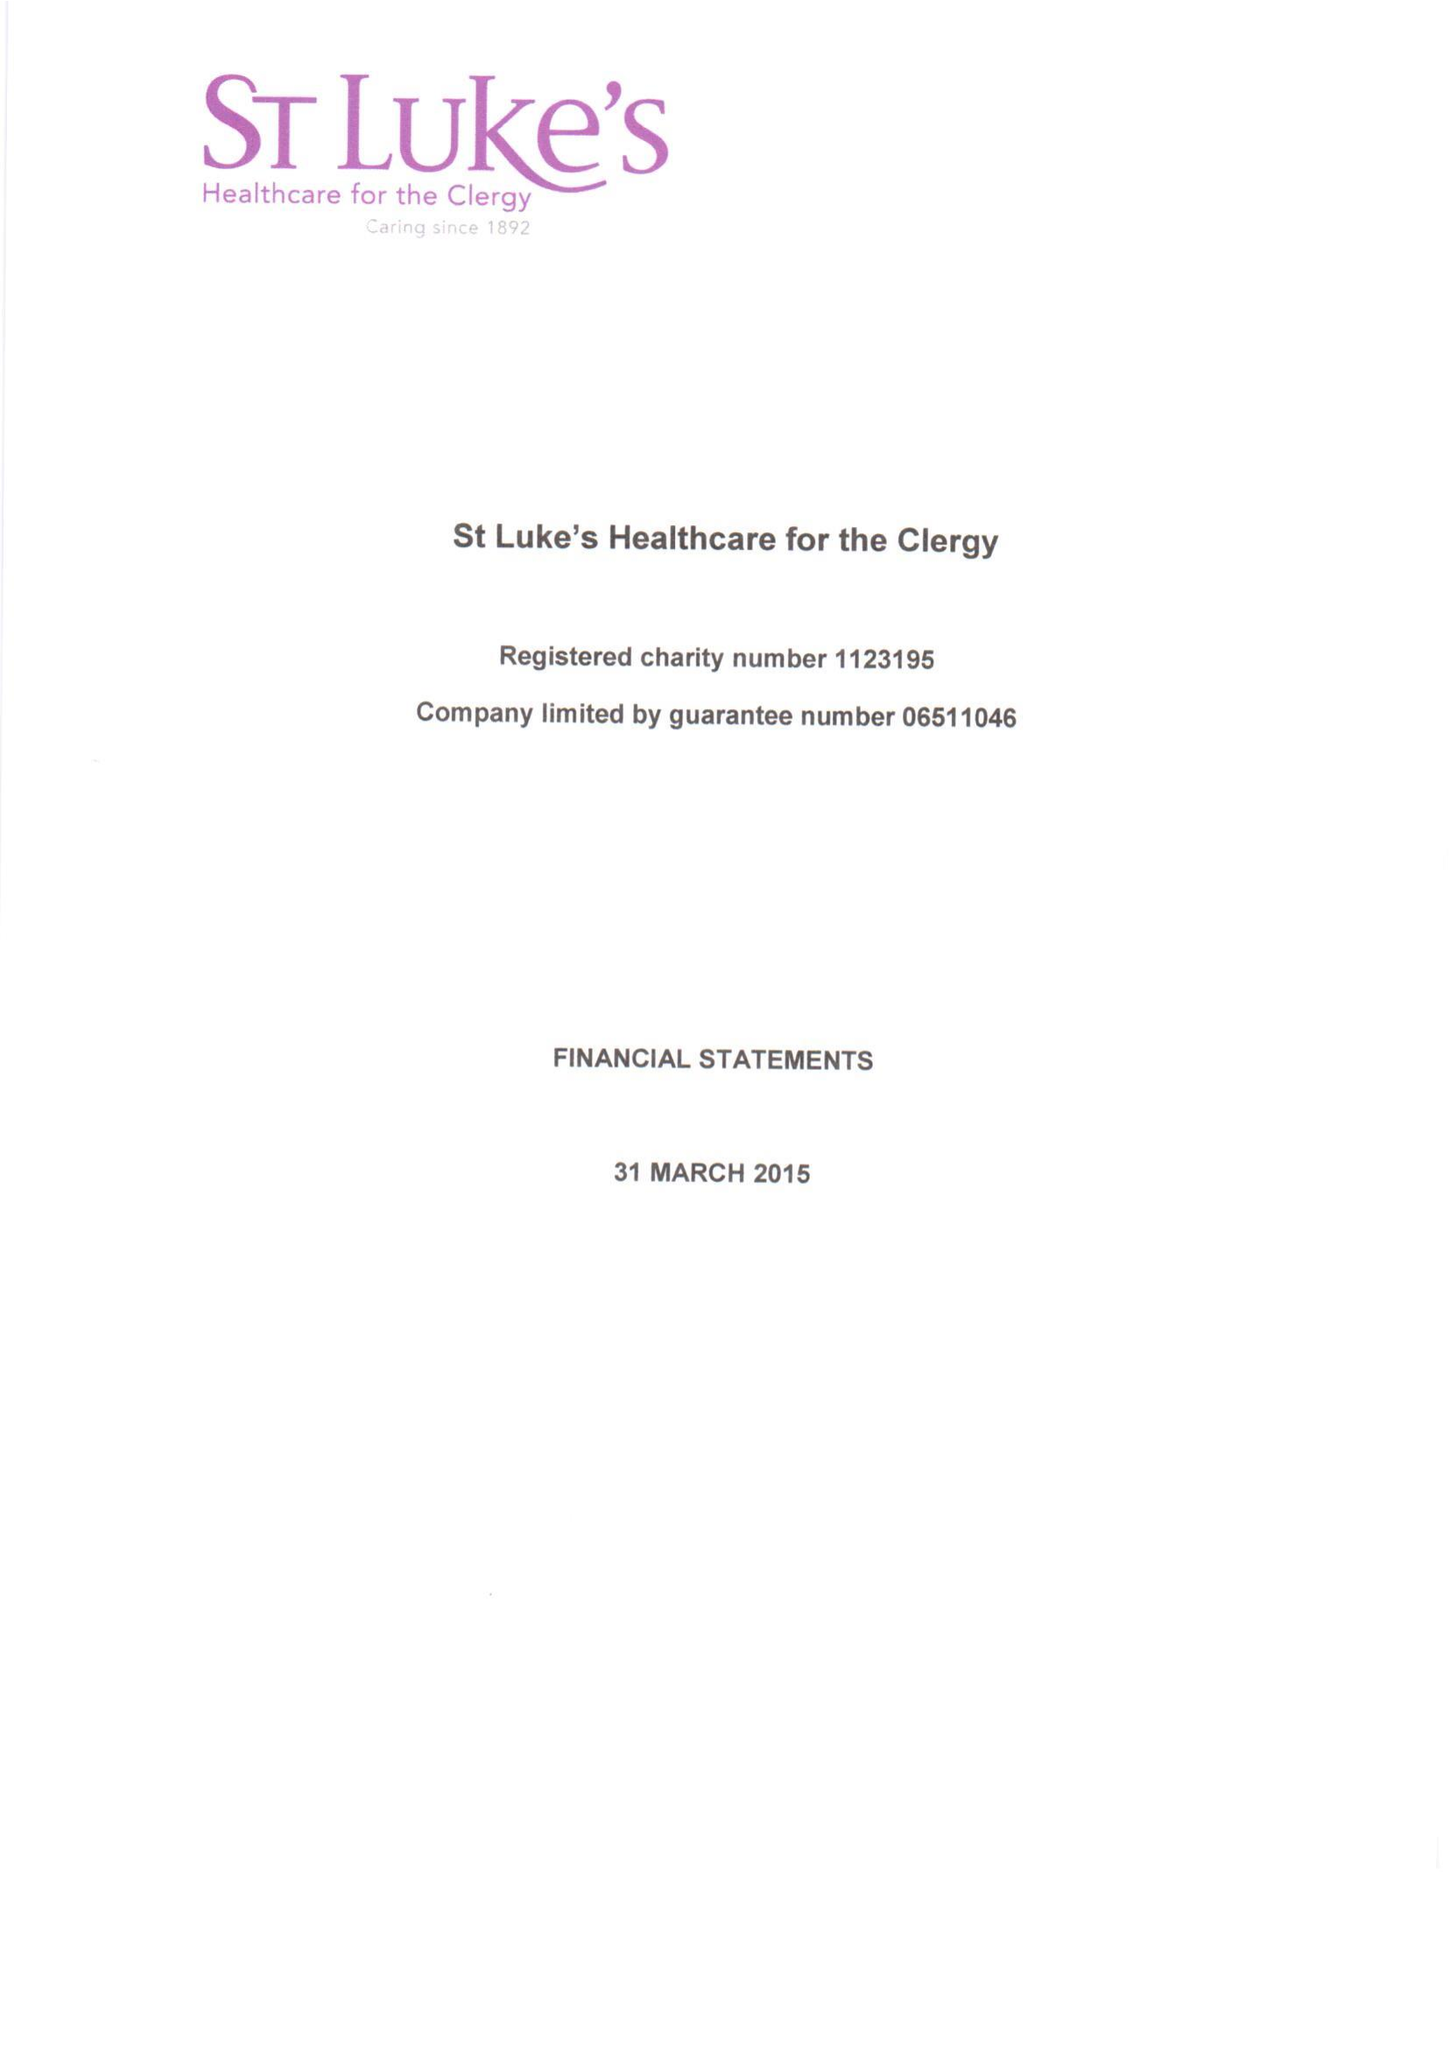What is the value for the charity_number?
Answer the question using a single word or phrase. 1123195 